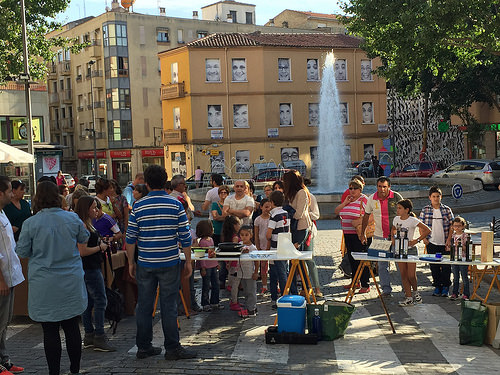<image>
Is there a man behind the table? No. The man is not behind the table. From this viewpoint, the man appears to be positioned elsewhere in the scene. 